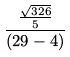<formula> <loc_0><loc_0><loc_500><loc_500>\frac { \frac { \sqrt { 3 2 6 } } { 5 } } { ( 2 9 - 4 ) }</formula> 